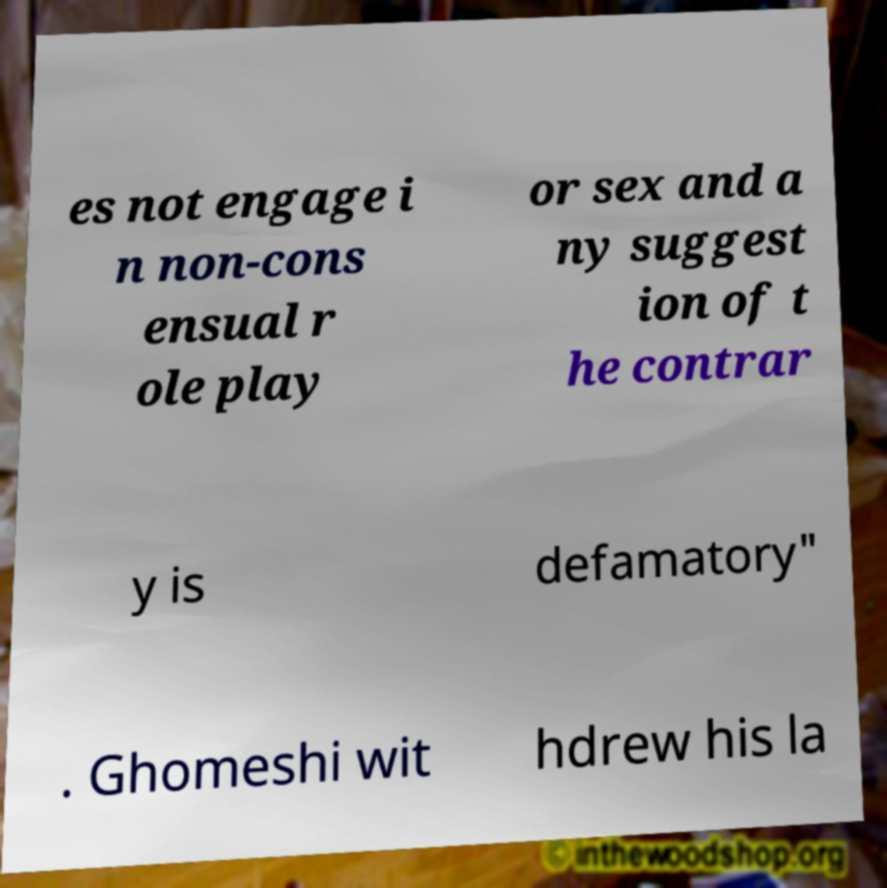Could you extract and type out the text from this image? es not engage i n non-cons ensual r ole play or sex and a ny suggest ion of t he contrar y is defamatory" . Ghomeshi wit hdrew his la 